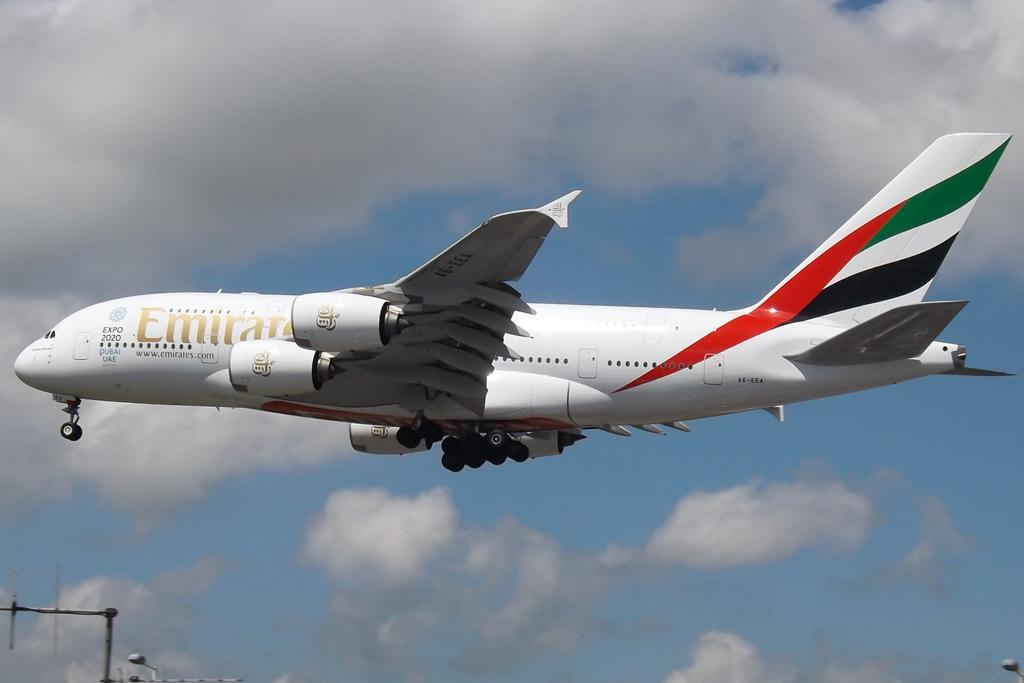<image>
Relay a brief, clear account of the picture shown. a plane with the word Emirates on the side of it 